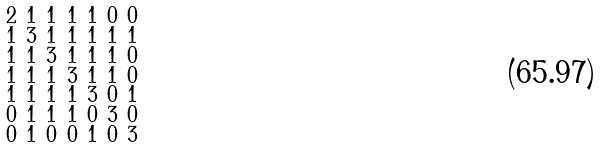<formula> <loc_0><loc_0><loc_500><loc_500>\begin{smallmatrix} 2 & 1 & 1 & 1 & 1 & 0 & 0 \\ 1 & 3 & 1 & 1 & 1 & 1 & 1 \\ 1 & 1 & 3 & 1 & 1 & 1 & 0 \\ 1 & 1 & 1 & 3 & 1 & 1 & 0 \\ 1 & 1 & 1 & 1 & 3 & 0 & 1 \\ 0 & 1 & 1 & 1 & 0 & 3 & 0 \\ 0 & 1 & 0 & 0 & 1 & 0 & 3 \end{smallmatrix}</formula> 